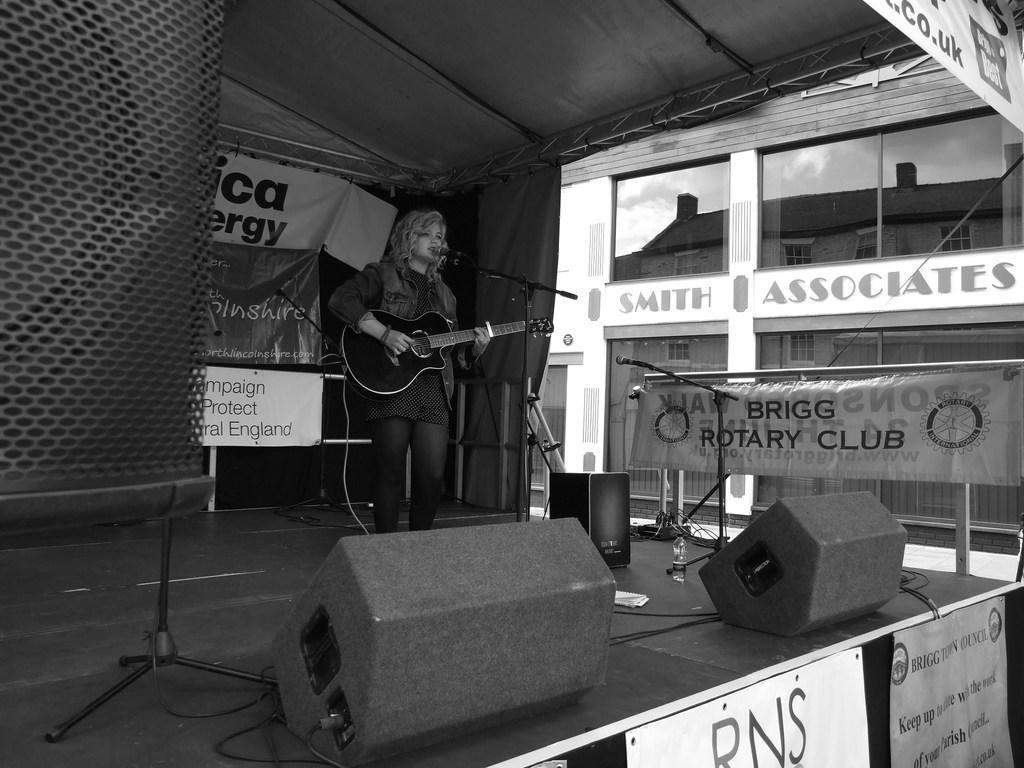In one or two sentences, can you explain what this image depicts? I see this is a black and white image and I see number of banners on which there is something written and I see logos and I see few things over here and I see a woman over here who is standing and I see that she is holding a guitar in her hands and I see the tripods on which there are mics. In the background I see a building and I see something is written over here too. 